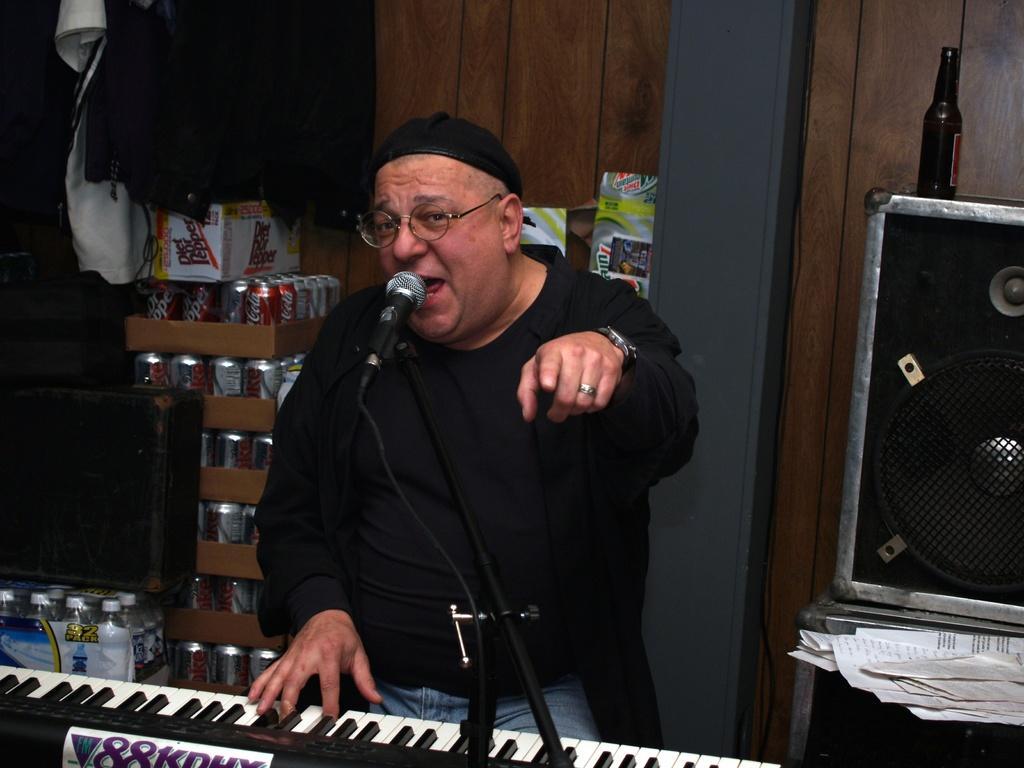Can you describe this image briefly? In the center we can see one man he is sitting and we can see he is singing. And in front of him we can see the microphone. Bottom we can see the keyboard. And coming to the background we can see the cans,water bottles and speaker. 